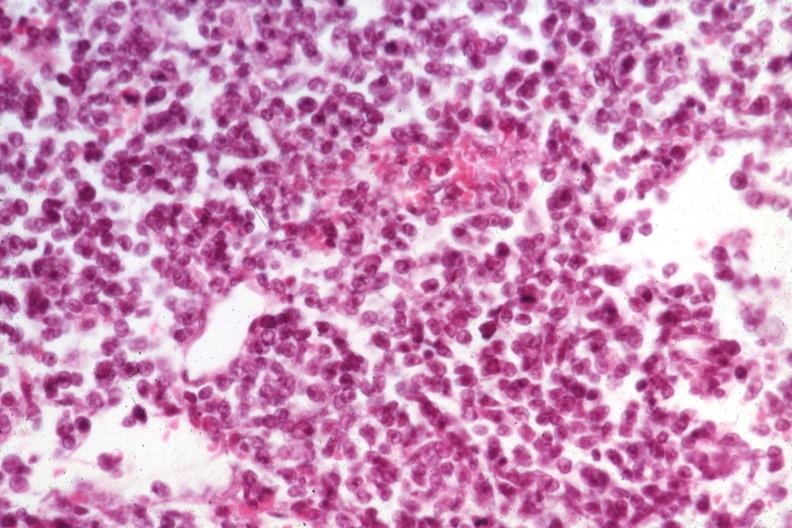what is present?
Answer the question using a single word or phrase. Lymph node 